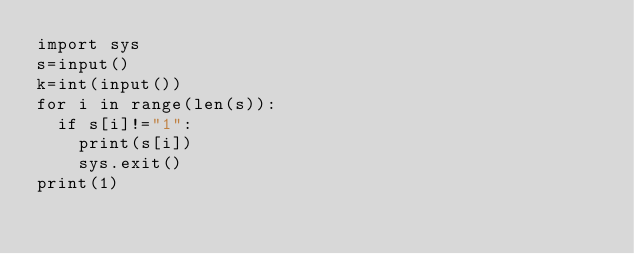<code> <loc_0><loc_0><loc_500><loc_500><_Python_>import sys
s=input()
k=int(input())
for i in range(len(s)):
  if s[i]!="1":
    print(s[i])
    sys.exit()
print(1)
</code> 